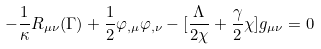Convert formula to latex. <formula><loc_0><loc_0><loc_500><loc_500>- \frac { 1 } { \kappa } R _ { \mu \nu } ( \Gamma ) + \frac { 1 } { 2 } \varphi _ { , \mu } \varphi _ { , \nu } - [ \frac { \Lambda } { 2 \chi } + \frac { \gamma } { 2 } \chi ] g _ { \mu \nu } = 0</formula> 